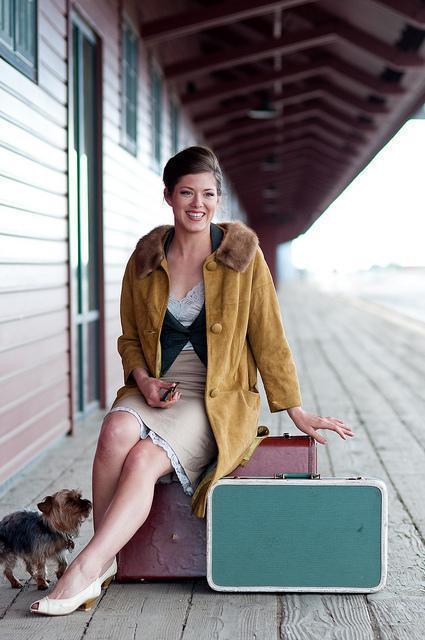How many suitcases are visible?
Give a very brief answer. 2. How many horses are looking at the camera?
Give a very brief answer. 0. 